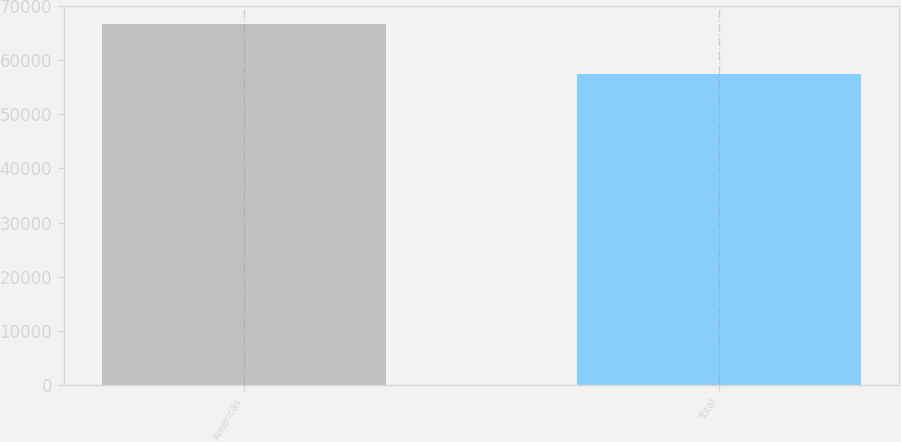Convert chart. <chart><loc_0><loc_0><loc_500><loc_500><bar_chart><fcel>Americas<fcel>Total<nl><fcel>66714<fcel>57494<nl></chart> 